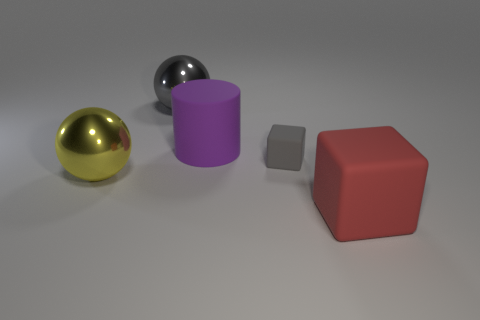Add 1 big yellow things. How many objects exist? 6 Subtract all blocks. How many objects are left? 3 Subtract 0 red cylinders. How many objects are left? 5 Subtract all large red objects. Subtract all yellow things. How many objects are left? 3 Add 5 red cubes. How many red cubes are left? 6 Add 3 large yellow cubes. How many large yellow cubes exist? 3 